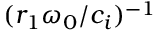Convert formula to latex. <formula><loc_0><loc_0><loc_500><loc_500>( r _ { 1 } \omega _ { 0 } / c _ { i } ) ^ { - 1 }</formula> 